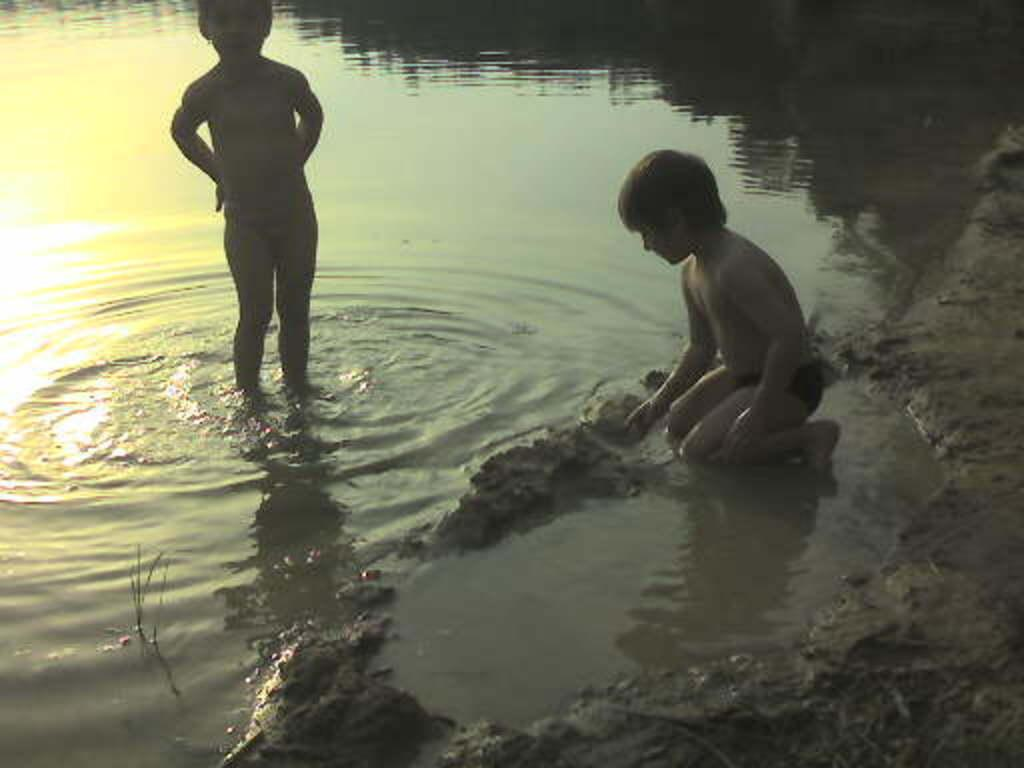How many kids are in the image? There are kids in the image. What is one of the kids doing in the image? One of the kids is sitting on his knees. What is at the bottom of the image? There is mud water at the bottom of the image. What type of support can be seen in the image? There is no specific support visible in the image. What disease might the kids be suffering from in the image? There is no indication of any disease in the image; the kids appear to be playing in mud water. 